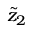Convert formula to latex. <formula><loc_0><loc_0><loc_500><loc_500>\tilde { z } _ { 2 }</formula> 